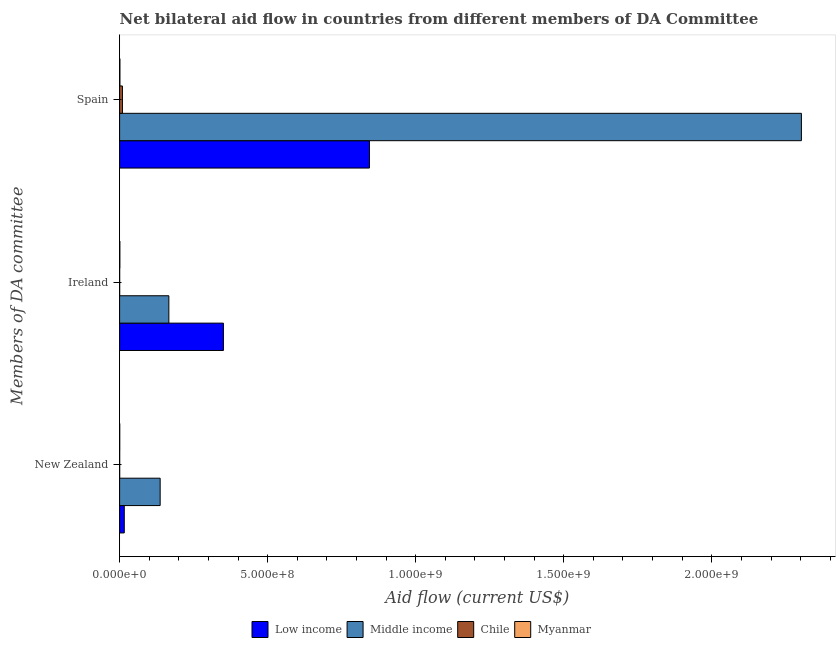How many groups of bars are there?
Keep it short and to the point. 3. How many bars are there on the 3rd tick from the top?
Give a very brief answer. 4. How many bars are there on the 1st tick from the bottom?
Provide a succinct answer. 4. What is the label of the 3rd group of bars from the top?
Give a very brief answer. New Zealand. What is the amount of aid provided by ireland in Low income?
Keep it short and to the point. 3.51e+08. Across all countries, what is the maximum amount of aid provided by ireland?
Provide a succinct answer. 3.51e+08. Across all countries, what is the minimum amount of aid provided by new zealand?
Ensure brevity in your answer.  2.40e+05. In which country was the amount of aid provided by spain minimum?
Keep it short and to the point. Myanmar. What is the total amount of aid provided by spain in the graph?
Your response must be concise. 3.16e+09. What is the difference between the amount of aid provided by ireland in Chile and that in Low income?
Ensure brevity in your answer.  -3.50e+08. What is the difference between the amount of aid provided by ireland in Low income and the amount of aid provided by new zealand in Myanmar?
Ensure brevity in your answer.  3.50e+08. What is the average amount of aid provided by ireland per country?
Provide a succinct answer. 1.29e+08. What is the difference between the amount of aid provided by spain and amount of aid provided by ireland in Low income?
Make the answer very short. 4.93e+08. What is the ratio of the amount of aid provided by spain in Chile to that in Myanmar?
Make the answer very short. 9.1. Is the amount of aid provided by spain in Low income less than that in Chile?
Make the answer very short. No. Is the difference between the amount of aid provided by new zealand in Myanmar and Middle income greater than the difference between the amount of aid provided by spain in Myanmar and Middle income?
Give a very brief answer. Yes. What is the difference between the highest and the second highest amount of aid provided by new zealand?
Offer a very short reply. 1.21e+08. What is the difference between the highest and the lowest amount of aid provided by ireland?
Keep it short and to the point. 3.50e+08. Is the sum of the amount of aid provided by spain in Middle income and Chile greater than the maximum amount of aid provided by ireland across all countries?
Make the answer very short. Yes. What does the 1st bar from the top in Ireland represents?
Keep it short and to the point. Myanmar. What does the 4th bar from the bottom in New Zealand represents?
Your answer should be very brief. Myanmar. How many bars are there?
Offer a terse response. 12. How many countries are there in the graph?
Your answer should be compact. 4. Are the values on the major ticks of X-axis written in scientific E-notation?
Ensure brevity in your answer.  Yes. What is the title of the graph?
Keep it short and to the point. Net bilateral aid flow in countries from different members of DA Committee. What is the label or title of the X-axis?
Make the answer very short. Aid flow (current US$). What is the label or title of the Y-axis?
Your response must be concise. Members of DA committee. What is the Aid flow (current US$) in Low income in New Zealand?
Keep it short and to the point. 1.58e+07. What is the Aid flow (current US$) in Middle income in New Zealand?
Your response must be concise. 1.37e+08. What is the Aid flow (current US$) of Low income in Ireland?
Ensure brevity in your answer.  3.51e+08. What is the Aid flow (current US$) in Middle income in Ireland?
Make the answer very short. 1.66e+08. What is the Aid flow (current US$) of Myanmar in Ireland?
Keep it short and to the point. 8.30e+05. What is the Aid flow (current US$) in Low income in Spain?
Give a very brief answer. 8.44e+08. What is the Aid flow (current US$) of Middle income in Spain?
Provide a succinct answer. 2.30e+09. What is the Aid flow (current US$) in Chile in Spain?
Your response must be concise. 9.56e+06. What is the Aid flow (current US$) in Myanmar in Spain?
Provide a short and direct response. 1.05e+06. Across all Members of DA committee, what is the maximum Aid flow (current US$) of Low income?
Your answer should be very brief. 8.44e+08. Across all Members of DA committee, what is the maximum Aid flow (current US$) in Middle income?
Ensure brevity in your answer.  2.30e+09. Across all Members of DA committee, what is the maximum Aid flow (current US$) in Chile?
Ensure brevity in your answer.  9.56e+06. Across all Members of DA committee, what is the maximum Aid flow (current US$) in Myanmar?
Keep it short and to the point. 1.05e+06. Across all Members of DA committee, what is the minimum Aid flow (current US$) of Low income?
Offer a very short reply. 1.58e+07. Across all Members of DA committee, what is the minimum Aid flow (current US$) in Middle income?
Offer a very short reply. 1.37e+08. Across all Members of DA committee, what is the minimum Aid flow (current US$) of Chile?
Ensure brevity in your answer.  1.70e+05. Across all Members of DA committee, what is the minimum Aid flow (current US$) of Myanmar?
Offer a very short reply. 4.20e+05. What is the total Aid flow (current US$) of Low income in the graph?
Provide a succinct answer. 1.21e+09. What is the total Aid flow (current US$) in Middle income in the graph?
Your response must be concise. 2.61e+09. What is the total Aid flow (current US$) in Chile in the graph?
Your answer should be very brief. 9.97e+06. What is the total Aid flow (current US$) of Myanmar in the graph?
Your response must be concise. 2.30e+06. What is the difference between the Aid flow (current US$) of Low income in New Zealand and that in Ireland?
Your answer should be very brief. -3.35e+08. What is the difference between the Aid flow (current US$) of Middle income in New Zealand and that in Ireland?
Your answer should be very brief. -2.94e+07. What is the difference between the Aid flow (current US$) of Chile in New Zealand and that in Ireland?
Keep it short and to the point. 7.00e+04. What is the difference between the Aid flow (current US$) in Myanmar in New Zealand and that in Ireland?
Make the answer very short. -4.10e+05. What is the difference between the Aid flow (current US$) in Low income in New Zealand and that in Spain?
Your response must be concise. -8.28e+08. What is the difference between the Aid flow (current US$) in Middle income in New Zealand and that in Spain?
Make the answer very short. -2.17e+09. What is the difference between the Aid flow (current US$) in Chile in New Zealand and that in Spain?
Your response must be concise. -9.32e+06. What is the difference between the Aid flow (current US$) in Myanmar in New Zealand and that in Spain?
Make the answer very short. -6.30e+05. What is the difference between the Aid flow (current US$) in Low income in Ireland and that in Spain?
Provide a succinct answer. -4.93e+08. What is the difference between the Aid flow (current US$) of Middle income in Ireland and that in Spain?
Ensure brevity in your answer.  -2.14e+09. What is the difference between the Aid flow (current US$) of Chile in Ireland and that in Spain?
Provide a short and direct response. -9.39e+06. What is the difference between the Aid flow (current US$) of Low income in New Zealand and the Aid flow (current US$) of Middle income in Ireland?
Give a very brief answer. -1.51e+08. What is the difference between the Aid flow (current US$) in Low income in New Zealand and the Aid flow (current US$) in Chile in Ireland?
Provide a succinct answer. 1.56e+07. What is the difference between the Aid flow (current US$) in Low income in New Zealand and the Aid flow (current US$) in Myanmar in Ireland?
Your response must be concise. 1.50e+07. What is the difference between the Aid flow (current US$) in Middle income in New Zealand and the Aid flow (current US$) in Chile in Ireland?
Offer a very short reply. 1.37e+08. What is the difference between the Aid flow (current US$) in Middle income in New Zealand and the Aid flow (current US$) in Myanmar in Ireland?
Keep it short and to the point. 1.36e+08. What is the difference between the Aid flow (current US$) in Chile in New Zealand and the Aid flow (current US$) in Myanmar in Ireland?
Provide a short and direct response. -5.90e+05. What is the difference between the Aid flow (current US$) in Low income in New Zealand and the Aid flow (current US$) in Middle income in Spain?
Provide a succinct answer. -2.29e+09. What is the difference between the Aid flow (current US$) in Low income in New Zealand and the Aid flow (current US$) in Chile in Spain?
Offer a very short reply. 6.23e+06. What is the difference between the Aid flow (current US$) of Low income in New Zealand and the Aid flow (current US$) of Myanmar in Spain?
Provide a short and direct response. 1.47e+07. What is the difference between the Aid flow (current US$) of Middle income in New Zealand and the Aid flow (current US$) of Chile in Spain?
Offer a terse response. 1.27e+08. What is the difference between the Aid flow (current US$) in Middle income in New Zealand and the Aid flow (current US$) in Myanmar in Spain?
Your answer should be compact. 1.36e+08. What is the difference between the Aid flow (current US$) of Chile in New Zealand and the Aid flow (current US$) of Myanmar in Spain?
Your answer should be compact. -8.10e+05. What is the difference between the Aid flow (current US$) in Low income in Ireland and the Aid flow (current US$) in Middle income in Spain?
Keep it short and to the point. -1.95e+09. What is the difference between the Aid flow (current US$) in Low income in Ireland and the Aid flow (current US$) in Chile in Spain?
Offer a very short reply. 3.41e+08. What is the difference between the Aid flow (current US$) of Low income in Ireland and the Aid flow (current US$) of Myanmar in Spain?
Your answer should be compact. 3.50e+08. What is the difference between the Aid flow (current US$) in Middle income in Ireland and the Aid flow (current US$) in Chile in Spain?
Provide a short and direct response. 1.57e+08. What is the difference between the Aid flow (current US$) of Middle income in Ireland and the Aid flow (current US$) of Myanmar in Spain?
Ensure brevity in your answer.  1.65e+08. What is the difference between the Aid flow (current US$) in Chile in Ireland and the Aid flow (current US$) in Myanmar in Spain?
Your answer should be very brief. -8.80e+05. What is the average Aid flow (current US$) of Low income per Members of DA committee?
Offer a terse response. 4.03e+08. What is the average Aid flow (current US$) of Middle income per Members of DA committee?
Keep it short and to the point. 8.69e+08. What is the average Aid flow (current US$) in Chile per Members of DA committee?
Ensure brevity in your answer.  3.32e+06. What is the average Aid flow (current US$) of Myanmar per Members of DA committee?
Ensure brevity in your answer.  7.67e+05. What is the difference between the Aid flow (current US$) in Low income and Aid flow (current US$) in Middle income in New Zealand?
Ensure brevity in your answer.  -1.21e+08. What is the difference between the Aid flow (current US$) in Low income and Aid flow (current US$) in Chile in New Zealand?
Make the answer very short. 1.56e+07. What is the difference between the Aid flow (current US$) in Low income and Aid flow (current US$) in Myanmar in New Zealand?
Offer a very short reply. 1.54e+07. What is the difference between the Aid flow (current US$) of Middle income and Aid flow (current US$) of Chile in New Zealand?
Make the answer very short. 1.37e+08. What is the difference between the Aid flow (current US$) of Middle income and Aid flow (current US$) of Myanmar in New Zealand?
Provide a succinct answer. 1.37e+08. What is the difference between the Aid flow (current US$) of Low income and Aid flow (current US$) of Middle income in Ireland?
Ensure brevity in your answer.  1.84e+08. What is the difference between the Aid flow (current US$) in Low income and Aid flow (current US$) in Chile in Ireland?
Offer a very short reply. 3.50e+08. What is the difference between the Aid flow (current US$) in Low income and Aid flow (current US$) in Myanmar in Ireland?
Offer a terse response. 3.50e+08. What is the difference between the Aid flow (current US$) in Middle income and Aid flow (current US$) in Chile in Ireland?
Provide a succinct answer. 1.66e+08. What is the difference between the Aid flow (current US$) in Middle income and Aid flow (current US$) in Myanmar in Ireland?
Provide a short and direct response. 1.66e+08. What is the difference between the Aid flow (current US$) of Chile and Aid flow (current US$) of Myanmar in Ireland?
Your answer should be compact. -6.60e+05. What is the difference between the Aid flow (current US$) in Low income and Aid flow (current US$) in Middle income in Spain?
Your answer should be very brief. -1.46e+09. What is the difference between the Aid flow (current US$) in Low income and Aid flow (current US$) in Chile in Spain?
Ensure brevity in your answer.  8.34e+08. What is the difference between the Aid flow (current US$) in Low income and Aid flow (current US$) in Myanmar in Spain?
Provide a short and direct response. 8.43e+08. What is the difference between the Aid flow (current US$) of Middle income and Aid flow (current US$) of Chile in Spain?
Offer a very short reply. 2.29e+09. What is the difference between the Aid flow (current US$) in Middle income and Aid flow (current US$) in Myanmar in Spain?
Your answer should be very brief. 2.30e+09. What is the difference between the Aid flow (current US$) in Chile and Aid flow (current US$) in Myanmar in Spain?
Make the answer very short. 8.51e+06. What is the ratio of the Aid flow (current US$) in Low income in New Zealand to that in Ireland?
Give a very brief answer. 0.04. What is the ratio of the Aid flow (current US$) in Middle income in New Zealand to that in Ireland?
Offer a very short reply. 0.82. What is the ratio of the Aid flow (current US$) in Chile in New Zealand to that in Ireland?
Offer a very short reply. 1.41. What is the ratio of the Aid flow (current US$) in Myanmar in New Zealand to that in Ireland?
Your response must be concise. 0.51. What is the ratio of the Aid flow (current US$) in Low income in New Zealand to that in Spain?
Your answer should be very brief. 0.02. What is the ratio of the Aid flow (current US$) of Middle income in New Zealand to that in Spain?
Your response must be concise. 0.06. What is the ratio of the Aid flow (current US$) of Chile in New Zealand to that in Spain?
Give a very brief answer. 0.03. What is the ratio of the Aid flow (current US$) of Low income in Ireland to that in Spain?
Your answer should be very brief. 0.42. What is the ratio of the Aid flow (current US$) in Middle income in Ireland to that in Spain?
Offer a very short reply. 0.07. What is the ratio of the Aid flow (current US$) of Chile in Ireland to that in Spain?
Your answer should be very brief. 0.02. What is the ratio of the Aid flow (current US$) of Myanmar in Ireland to that in Spain?
Provide a short and direct response. 0.79. What is the difference between the highest and the second highest Aid flow (current US$) of Low income?
Ensure brevity in your answer.  4.93e+08. What is the difference between the highest and the second highest Aid flow (current US$) in Middle income?
Your answer should be compact. 2.14e+09. What is the difference between the highest and the second highest Aid flow (current US$) in Chile?
Offer a very short reply. 9.32e+06. What is the difference between the highest and the second highest Aid flow (current US$) of Myanmar?
Give a very brief answer. 2.20e+05. What is the difference between the highest and the lowest Aid flow (current US$) of Low income?
Your response must be concise. 8.28e+08. What is the difference between the highest and the lowest Aid flow (current US$) of Middle income?
Offer a very short reply. 2.17e+09. What is the difference between the highest and the lowest Aid flow (current US$) of Chile?
Your answer should be very brief. 9.39e+06. What is the difference between the highest and the lowest Aid flow (current US$) of Myanmar?
Offer a very short reply. 6.30e+05. 